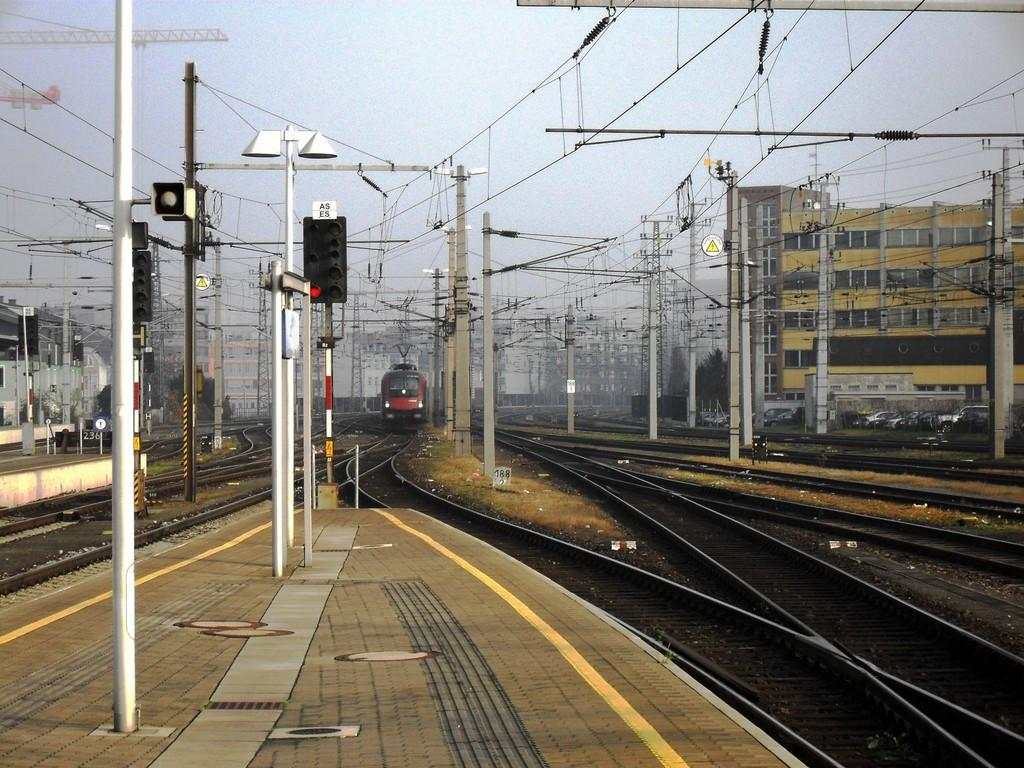What is the main structure in the image? There is a platform in the image. What type of transportation system is associated with the platform? Railway tracks are present in the image. What mode of transportation can be seen on the railway tracks? There is an electric train in the image. What supports the wires in the image? Poles are visible in the image. What are the wires used for? Wires are present in the image. What can be seen in the background of the image? There is a building in the background of the image. What type of harmony can be heard in the image? There is no audible sound in the image, so it is not possible to determine if any harmony can be heard. 